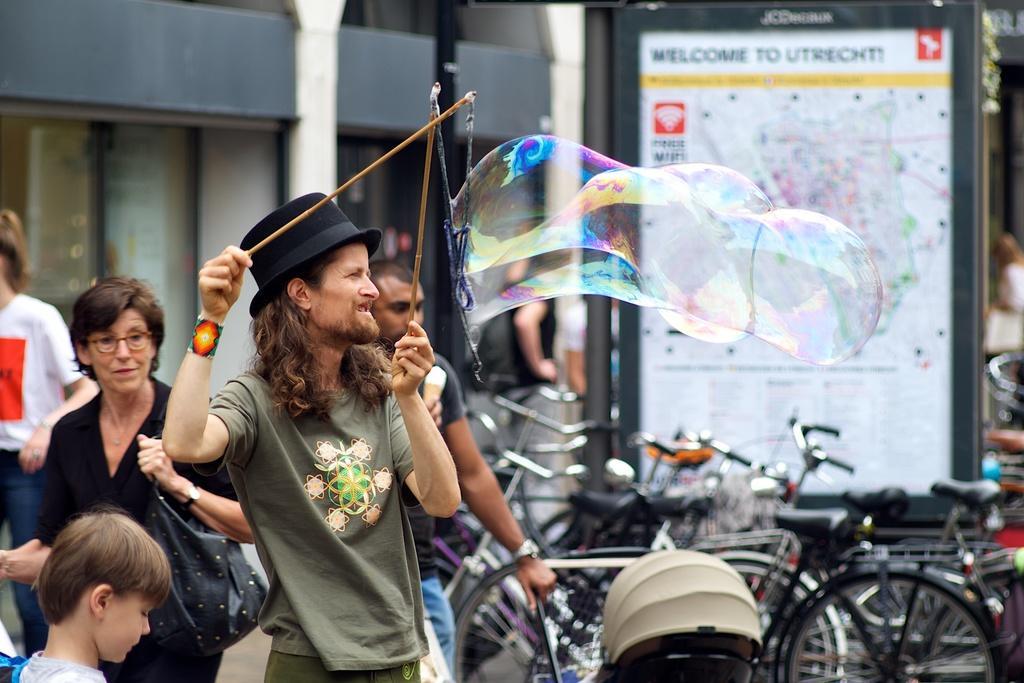In one or two sentences, can you explain what this image depicts? In this image, I can see few people standing. A man is holding the wooden sticks with ropes with a bubble. On the right side of the image, there are bicycles. In the background, I can see a board and a building. 